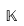<formula> <loc_0><loc_0><loc_500><loc_500>\mathbb { K }</formula> 